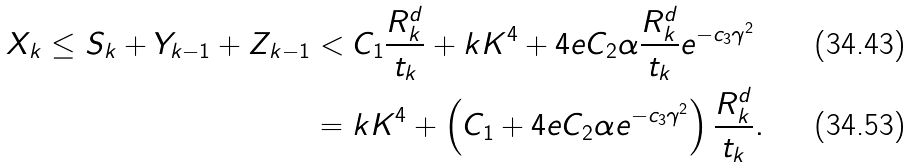Convert formula to latex. <formula><loc_0><loc_0><loc_500><loc_500>X _ { k } \leq S _ { k } + Y _ { k - 1 } + Z _ { k - 1 } & < C _ { 1 } \frac { R _ { k } ^ { d } } { t _ { k } } + k K ^ { 4 } + 4 e C _ { 2 } \alpha \frac { R _ { k } ^ { d } } { t _ { k } } e ^ { - c _ { 3 } \gamma ^ { 2 } } \\ & = k K ^ { 4 } + \left ( C _ { 1 } + 4 e C _ { 2 } \alpha e ^ { - c _ { 3 } \gamma ^ { 2 } } \right ) \frac { R _ { k } ^ { d } } { t _ { k } } .</formula> 